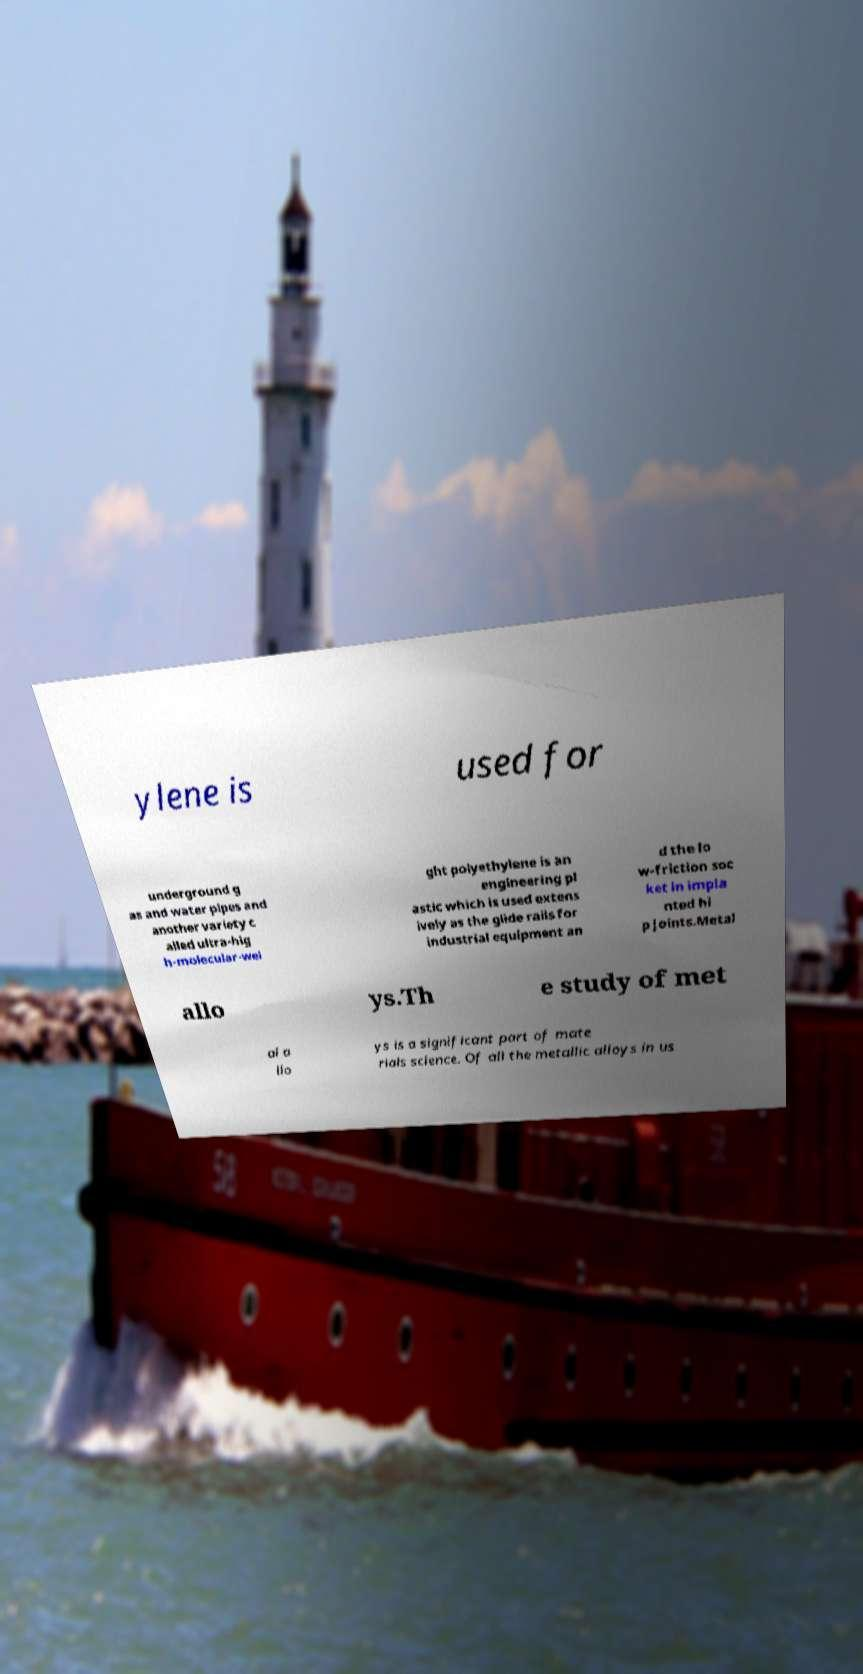What messages or text are displayed in this image? I need them in a readable, typed format. ylene is used for underground g as and water pipes and another variety c alled ultra-hig h-molecular-wei ght polyethylene is an engineering pl astic which is used extens ively as the glide rails for industrial equipment an d the lo w-friction soc ket in impla nted hi p joints.Metal allo ys.Th e study of met al a llo ys is a significant part of mate rials science. Of all the metallic alloys in us 